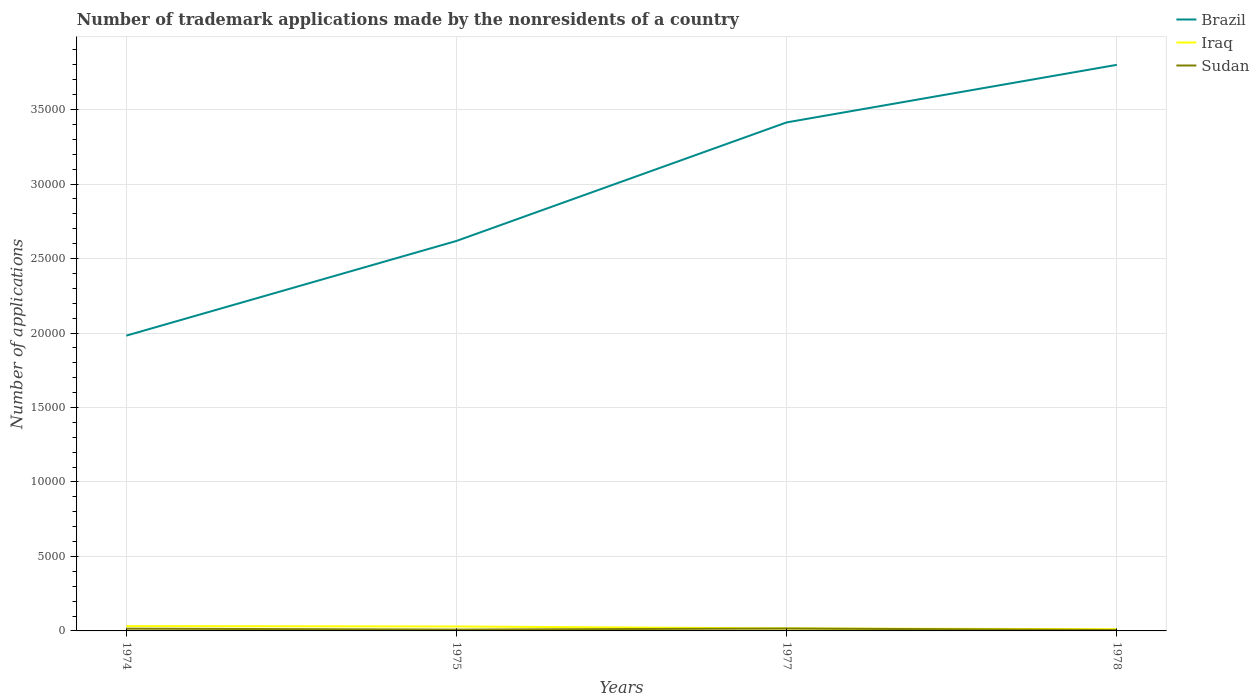Is the number of lines equal to the number of legend labels?
Provide a succinct answer. Yes. In which year was the number of trademark applications made by the nonresidents in Sudan maximum?
Keep it short and to the point. 1978. What is the total number of trademark applications made by the nonresidents in Brazil in the graph?
Your answer should be compact. -3864. What is the difference between the highest and the second highest number of trademark applications made by the nonresidents in Iraq?
Offer a very short reply. 208. Is the number of trademark applications made by the nonresidents in Sudan strictly greater than the number of trademark applications made by the nonresidents in Brazil over the years?
Provide a short and direct response. Yes. How many lines are there?
Keep it short and to the point. 3. How many years are there in the graph?
Your response must be concise. 4. What is the difference between two consecutive major ticks on the Y-axis?
Offer a terse response. 5000. Does the graph contain any zero values?
Offer a terse response. No. Does the graph contain grids?
Provide a succinct answer. Yes. How many legend labels are there?
Your answer should be very brief. 3. What is the title of the graph?
Give a very brief answer. Number of trademark applications made by the nonresidents of a country. Does "Chile" appear as one of the legend labels in the graph?
Provide a short and direct response. No. What is the label or title of the Y-axis?
Provide a succinct answer. Number of applications. What is the Number of applications in Brazil in 1974?
Make the answer very short. 1.98e+04. What is the Number of applications of Iraq in 1974?
Make the answer very short. 322. What is the Number of applications in Sudan in 1974?
Make the answer very short. 152. What is the Number of applications in Brazil in 1975?
Make the answer very short. 2.62e+04. What is the Number of applications of Iraq in 1975?
Give a very brief answer. 299. What is the Number of applications of Sudan in 1975?
Your answer should be compact. 89. What is the Number of applications in Brazil in 1977?
Offer a very short reply. 3.41e+04. What is the Number of applications of Iraq in 1977?
Your response must be concise. 166. What is the Number of applications of Sudan in 1977?
Provide a short and direct response. 161. What is the Number of applications in Brazil in 1978?
Ensure brevity in your answer.  3.80e+04. What is the Number of applications in Iraq in 1978?
Keep it short and to the point. 114. What is the Number of applications of Sudan in 1978?
Your response must be concise. 65. Across all years, what is the maximum Number of applications of Brazil?
Make the answer very short. 3.80e+04. Across all years, what is the maximum Number of applications of Iraq?
Offer a very short reply. 322. Across all years, what is the maximum Number of applications in Sudan?
Your response must be concise. 161. Across all years, what is the minimum Number of applications in Brazil?
Give a very brief answer. 1.98e+04. Across all years, what is the minimum Number of applications of Iraq?
Keep it short and to the point. 114. Across all years, what is the minimum Number of applications in Sudan?
Your answer should be compact. 65. What is the total Number of applications of Brazil in the graph?
Give a very brief answer. 1.18e+05. What is the total Number of applications in Iraq in the graph?
Your answer should be compact. 901. What is the total Number of applications of Sudan in the graph?
Offer a terse response. 467. What is the difference between the Number of applications in Brazil in 1974 and that in 1975?
Your answer should be compact. -6358. What is the difference between the Number of applications of Iraq in 1974 and that in 1975?
Make the answer very short. 23. What is the difference between the Number of applications of Sudan in 1974 and that in 1975?
Keep it short and to the point. 63. What is the difference between the Number of applications of Brazil in 1974 and that in 1977?
Your answer should be very brief. -1.43e+04. What is the difference between the Number of applications of Iraq in 1974 and that in 1977?
Your answer should be compact. 156. What is the difference between the Number of applications of Brazil in 1974 and that in 1978?
Provide a short and direct response. -1.82e+04. What is the difference between the Number of applications of Iraq in 1974 and that in 1978?
Offer a terse response. 208. What is the difference between the Number of applications in Brazil in 1975 and that in 1977?
Provide a succinct answer. -7959. What is the difference between the Number of applications in Iraq in 1975 and that in 1977?
Give a very brief answer. 133. What is the difference between the Number of applications in Sudan in 1975 and that in 1977?
Ensure brevity in your answer.  -72. What is the difference between the Number of applications in Brazil in 1975 and that in 1978?
Offer a terse response. -1.18e+04. What is the difference between the Number of applications of Iraq in 1975 and that in 1978?
Offer a very short reply. 185. What is the difference between the Number of applications of Sudan in 1975 and that in 1978?
Provide a short and direct response. 24. What is the difference between the Number of applications in Brazil in 1977 and that in 1978?
Your answer should be very brief. -3864. What is the difference between the Number of applications in Sudan in 1977 and that in 1978?
Make the answer very short. 96. What is the difference between the Number of applications of Brazil in 1974 and the Number of applications of Iraq in 1975?
Offer a terse response. 1.95e+04. What is the difference between the Number of applications of Brazil in 1974 and the Number of applications of Sudan in 1975?
Offer a terse response. 1.97e+04. What is the difference between the Number of applications of Iraq in 1974 and the Number of applications of Sudan in 1975?
Ensure brevity in your answer.  233. What is the difference between the Number of applications of Brazil in 1974 and the Number of applications of Iraq in 1977?
Provide a short and direct response. 1.97e+04. What is the difference between the Number of applications of Brazil in 1974 and the Number of applications of Sudan in 1977?
Offer a terse response. 1.97e+04. What is the difference between the Number of applications of Iraq in 1974 and the Number of applications of Sudan in 1977?
Your answer should be very brief. 161. What is the difference between the Number of applications in Brazil in 1974 and the Number of applications in Iraq in 1978?
Ensure brevity in your answer.  1.97e+04. What is the difference between the Number of applications in Brazil in 1974 and the Number of applications in Sudan in 1978?
Give a very brief answer. 1.98e+04. What is the difference between the Number of applications of Iraq in 1974 and the Number of applications of Sudan in 1978?
Provide a succinct answer. 257. What is the difference between the Number of applications of Brazil in 1975 and the Number of applications of Iraq in 1977?
Keep it short and to the point. 2.60e+04. What is the difference between the Number of applications in Brazil in 1975 and the Number of applications in Sudan in 1977?
Offer a very short reply. 2.60e+04. What is the difference between the Number of applications in Iraq in 1975 and the Number of applications in Sudan in 1977?
Make the answer very short. 138. What is the difference between the Number of applications of Brazil in 1975 and the Number of applications of Iraq in 1978?
Your response must be concise. 2.61e+04. What is the difference between the Number of applications of Brazil in 1975 and the Number of applications of Sudan in 1978?
Make the answer very short. 2.61e+04. What is the difference between the Number of applications in Iraq in 1975 and the Number of applications in Sudan in 1978?
Provide a succinct answer. 234. What is the difference between the Number of applications in Brazil in 1977 and the Number of applications in Iraq in 1978?
Make the answer very short. 3.40e+04. What is the difference between the Number of applications in Brazil in 1977 and the Number of applications in Sudan in 1978?
Your response must be concise. 3.41e+04. What is the difference between the Number of applications in Iraq in 1977 and the Number of applications in Sudan in 1978?
Your answer should be very brief. 101. What is the average Number of applications in Brazil per year?
Ensure brevity in your answer.  2.95e+04. What is the average Number of applications in Iraq per year?
Provide a succinct answer. 225.25. What is the average Number of applications in Sudan per year?
Your answer should be very brief. 116.75. In the year 1974, what is the difference between the Number of applications in Brazil and Number of applications in Iraq?
Offer a very short reply. 1.95e+04. In the year 1974, what is the difference between the Number of applications of Brazil and Number of applications of Sudan?
Your answer should be compact. 1.97e+04. In the year 1974, what is the difference between the Number of applications of Iraq and Number of applications of Sudan?
Your answer should be very brief. 170. In the year 1975, what is the difference between the Number of applications in Brazil and Number of applications in Iraq?
Offer a terse response. 2.59e+04. In the year 1975, what is the difference between the Number of applications of Brazil and Number of applications of Sudan?
Make the answer very short. 2.61e+04. In the year 1975, what is the difference between the Number of applications of Iraq and Number of applications of Sudan?
Give a very brief answer. 210. In the year 1977, what is the difference between the Number of applications of Brazil and Number of applications of Iraq?
Your response must be concise. 3.40e+04. In the year 1977, what is the difference between the Number of applications in Brazil and Number of applications in Sudan?
Your answer should be very brief. 3.40e+04. In the year 1978, what is the difference between the Number of applications of Brazil and Number of applications of Iraq?
Your answer should be very brief. 3.79e+04. In the year 1978, what is the difference between the Number of applications in Brazil and Number of applications in Sudan?
Your answer should be compact. 3.79e+04. What is the ratio of the Number of applications of Brazil in 1974 to that in 1975?
Give a very brief answer. 0.76. What is the ratio of the Number of applications of Iraq in 1974 to that in 1975?
Your answer should be compact. 1.08. What is the ratio of the Number of applications in Sudan in 1974 to that in 1975?
Make the answer very short. 1.71. What is the ratio of the Number of applications of Brazil in 1974 to that in 1977?
Ensure brevity in your answer.  0.58. What is the ratio of the Number of applications in Iraq in 1974 to that in 1977?
Make the answer very short. 1.94. What is the ratio of the Number of applications of Sudan in 1974 to that in 1977?
Your answer should be compact. 0.94. What is the ratio of the Number of applications of Brazil in 1974 to that in 1978?
Your response must be concise. 0.52. What is the ratio of the Number of applications of Iraq in 1974 to that in 1978?
Offer a very short reply. 2.82. What is the ratio of the Number of applications in Sudan in 1974 to that in 1978?
Provide a succinct answer. 2.34. What is the ratio of the Number of applications in Brazil in 1975 to that in 1977?
Ensure brevity in your answer.  0.77. What is the ratio of the Number of applications in Iraq in 1975 to that in 1977?
Provide a short and direct response. 1.8. What is the ratio of the Number of applications in Sudan in 1975 to that in 1977?
Offer a terse response. 0.55. What is the ratio of the Number of applications in Brazil in 1975 to that in 1978?
Make the answer very short. 0.69. What is the ratio of the Number of applications in Iraq in 1975 to that in 1978?
Ensure brevity in your answer.  2.62. What is the ratio of the Number of applications in Sudan in 1975 to that in 1978?
Make the answer very short. 1.37. What is the ratio of the Number of applications of Brazil in 1977 to that in 1978?
Ensure brevity in your answer.  0.9. What is the ratio of the Number of applications in Iraq in 1977 to that in 1978?
Offer a terse response. 1.46. What is the ratio of the Number of applications in Sudan in 1977 to that in 1978?
Keep it short and to the point. 2.48. What is the difference between the highest and the second highest Number of applications of Brazil?
Keep it short and to the point. 3864. What is the difference between the highest and the lowest Number of applications of Brazil?
Offer a very short reply. 1.82e+04. What is the difference between the highest and the lowest Number of applications in Iraq?
Your answer should be very brief. 208. What is the difference between the highest and the lowest Number of applications of Sudan?
Your response must be concise. 96. 